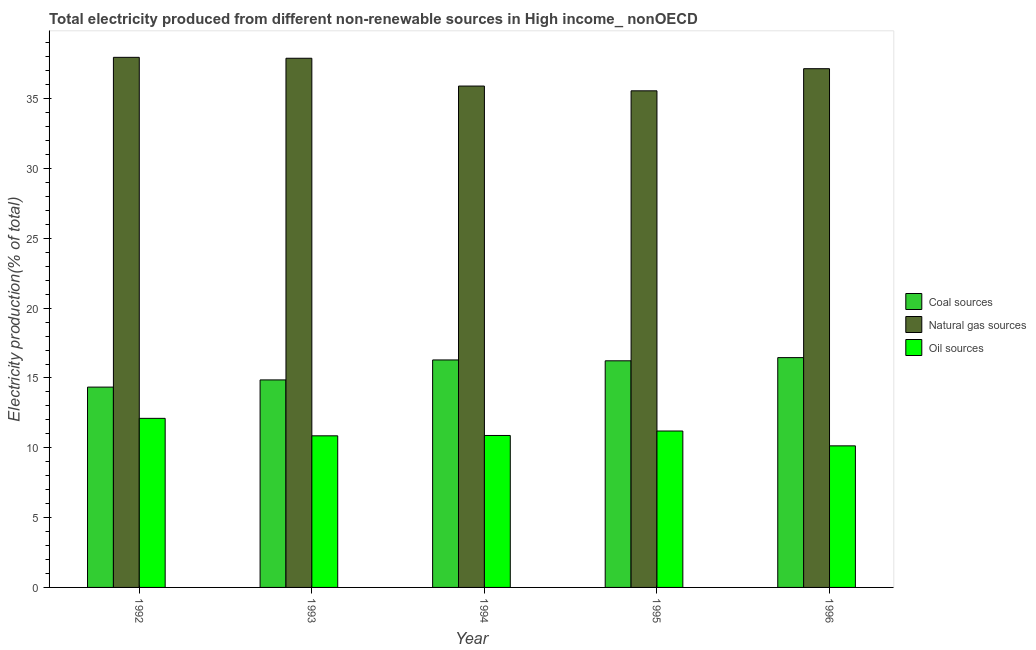How many bars are there on the 4th tick from the left?
Make the answer very short. 3. How many bars are there on the 3rd tick from the right?
Your answer should be compact. 3. What is the label of the 2nd group of bars from the left?
Your answer should be compact. 1993. What is the percentage of electricity produced by natural gas in 1996?
Offer a very short reply. 37.15. Across all years, what is the maximum percentage of electricity produced by oil sources?
Your answer should be very brief. 12.11. Across all years, what is the minimum percentage of electricity produced by coal?
Ensure brevity in your answer.  14.35. What is the total percentage of electricity produced by coal in the graph?
Your answer should be compact. 78.19. What is the difference between the percentage of electricity produced by coal in 1992 and that in 1994?
Provide a short and direct response. -1.95. What is the difference between the percentage of electricity produced by natural gas in 1993 and the percentage of electricity produced by coal in 1992?
Your response must be concise. -0.07. What is the average percentage of electricity produced by natural gas per year?
Your response must be concise. 36.9. In how many years, is the percentage of electricity produced by coal greater than 16 %?
Ensure brevity in your answer.  3. What is the ratio of the percentage of electricity produced by coal in 1993 to that in 1996?
Offer a terse response. 0.9. Is the difference between the percentage of electricity produced by oil sources in 1995 and 1996 greater than the difference between the percentage of electricity produced by natural gas in 1995 and 1996?
Keep it short and to the point. No. What is the difference between the highest and the second highest percentage of electricity produced by coal?
Offer a very short reply. 0.17. What is the difference between the highest and the lowest percentage of electricity produced by natural gas?
Offer a very short reply. 2.4. What does the 1st bar from the left in 1995 represents?
Keep it short and to the point. Coal sources. What does the 3rd bar from the right in 1992 represents?
Offer a terse response. Coal sources. Is it the case that in every year, the sum of the percentage of electricity produced by coal and percentage of electricity produced by natural gas is greater than the percentage of electricity produced by oil sources?
Your response must be concise. Yes. How many years are there in the graph?
Ensure brevity in your answer.  5. What is the difference between two consecutive major ticks on the Y-axis?
Keep it short and to the point. 5. Does the graph contain grids?
Offer a terse response. No. Where does the legend appear in the graph?
Offer a very short reply. Center right. How many legend labels are there?
Your answer should be compact. 3. What is the title of the graph?
Ensure brevity in your answer.  Total electricity produced from different non-renewable sources in High income_ nonOECD. What is the label or title of the X-axis?
Ensure brevity in your answer.  Year. What is the label or title of the Y-axis?
Your response must be concise. Electricity production(% of total). What is the Electricity production(% of total) of Coal sources in 1992?
Give a very brief answer. 14.35. What is the Electricity production(% of total) in Natural gas sources in 1992?
Make the answer very short. 37.97. What is the Electricity production(% of total) in Oil sources in 1992?
Your answer should be compact. 12.11. What is the Electricity production(% of total) in Coal sources in 1993?
Keep it short and to the point. 14.86. What is the Electricity production(% of total) in Natural gas sources in 1993?
Offer a terse response. 37.9. What is the Electricity production(% of total) in Oil sources in 1993?
Provide a short and direct response. 10.86. What is the Electricity production(% of total) in Coal sources in 1994?
Offer a terse response. 16.29. What is the Electricity production(% of total) of Natural gas sources in 1994?
Provide a succinct answer. 35.91. What is the Electricity production(% of total) in Oil sources in 1994?
Provide a succinct answer. 10.88. What is the Electricity production(% of total) in Coal sources in 1995?
Your answer should be very brief. 16.23. What is the Electricity production(% of total) of Natural gas sources in 1995?
Your response must be concise. 35.57. What is the Electricity production(% of total) in Oil sources in 1995?
Give a very brief answer. 11.2. What is the Electricity production(% of total) in Coal sources in 1996?
Provide a short and direct response. 16.46. What is the Electricity production(% of total) in Natural gas sources in 1996?
Give a very brief answer. 37.15. What is the Electricity production(% of total) in Oil sources in 1996?
Provide a short and direct response. 10.14. Across all years, what is the maximum Electricity production(% of total) in Coal sources?
Ensure brevity in your answer.  16.46. Across all years, what is the maximum Electricity production(% of total) in Natural gas sources?
Your answer should be compact. 37.97. Across all years, what is the maximum Electricity production(% of total) in Oil sources?
Offer a very short reply. 12.11. Across all years, what is the minimum Electricity production(% of total) of Coal sources?
Offer a very short reply. 14.35. Across all years, what is the minimum Electricity production(% of total) of Natural gas sources?
Offer a terse response. 35.57. Across all years, what is the minimum Electricity production(% of total) in Oil sources?
Provide a succinct answer. 10.14. What is the total Electricity production(% of total) of Coal sources in the graph?
Ensure brevity in your answer.  78.19. What is the total Electricity production(% of total) of Natural gas sources in the graph?
Your answer should be compact. 184.5. What is the total Electricity production(% of total) of Oil sources in the graph?
Keep it short and to the point. 55.19. What is the difference between the Electricity production(% of total) in Coal sources in 1992 and that in 1993?
Provide a short and direct response. -0.52. What is the difference between the Electricity production(% of total) in Natural gas sources in 1992 and that in 1993?
Ensure brevity in your answer.  0.07. What is the difference between the Electricity production(% of total) of Oil sources in 1992 and that in 1993?
Your response must be concise. 1.25. What is the difference between the Electricity production(% of total) in Coal sources in 1992 and that in 1994?
Offer a very short reply. -1.95. What is the difference between the Electricity production(% of total) in Natural gas sources in 1992 and that in 1994?
Ensure brevity in your answer.  2.06. What is the difference between the Electricity production(% of total) of Oil sources in 1992 and that in 1994?
Give a very brief answer. 1.23. What is the difference between the Electricity production(% of total) in Coal sources in 1992 and that in 1995?
Keep it short and to the point. -1.88. What is the difference between the Electricity production(% of total) in Natural gas sources in 1992 and that in 1995?
Provide a short and direct response. 2.4. What is the difference between the Electricity production(% of total) in Oil sources in 1992 and that in 1995?
Ensure brevity in your answer.  0.91. What is the difference between the Electricity production(% of total) of Coal sources in 1992 and that in 1996?
Ensure brevity in your answer.  -2.11. What is the difference between the Electricity production(% of total) of Natural gas sources in 1992 and that in 1996?
Your response must be concise. 0.81. What is the difference between the Electricity production(% of total) in Oil sources in 1992 and that in 1996?
Your answer should be very brief. 1.97. What is the difference between the Electricity production(% of total) of Coal sources in 1993 and that in 1994?
Provide a succinct answer. -1.43. What is the difference between the Electricity production(% of total) in Natural gas sources in 1993 and that in 1994?
Provide a succinct answer. 1.99. What is the difference between the Electricity production(% of total) in Oil sources in 1993 and that in 1994?
Provide a short and direct response. -0.02. What is the difference between the Electricity production(% of total) of Coal sources in 1993 and that in 1995?
Your response must be concise. -1.37. What is the difference between the Electricity production(% of total) in Natural gas sources in 1993 and that in 1995?
Your answer should be compact. 2.33. What is the difference between the Electricity production(% of total) of Oil sources in 1993 and that in 1995?
Offer a very short reply. -0.34. What is the difference between the Electricity production(% of total) of Coal sources in 1993 and that in 1996?
Your response must be concise. -1.6. What is the difference between the Electricity production(% of total) in Natural gas sources in 1993 and that in 1996?
Your answer should be compact. 0.75. What is the difference between the Electricity production(% of total) in Oil sources in 1993 and that in 1996?
Provide a succinct answer. 0.72. What is the difference between the Electricity production(% of total) in Coal sources in 1994 and that in 1995?
Your answer should be compact. 0.06. What is the difference between the Electricity production(% of total) in Natural gas sources in 1994 and that in 1995?
Keep it short and to the point. 0.34. What is the difference between the Electricity production(% of total) of Oil sources in 1994 and that in 1995?
Your response must be concise. -0.32. What is the difference between the Electricity production(% of total) of Coal sources in 1994 and that in 1996?
Provide a succinct answer. -0.17. What is the difference between the Electricity production(% of total) of Natural gas sources in 1994 and that in 1996?
Your response must be concise. -1.24. What is the difference between the Electricity production(% of total) of Oil sources in 1994 and that in 1996?
Your answer should be compact. 0.74. What is the difference between the Electricity production(% of total) of Coal sources in 1995 and that in 1996?
Your answer should be compact. -0.23. What is the difference between the Electricity production(% of total) of Natural gas sources in 1995 and that in 1996?
Make the answer very short. -1.58. What is the difference between the Electricity production(% of total) of Oil sources in 1995 and that in 1996?
Offer a terse response. 1.06. What is the difference between the Electricity production(% of total) in Coal sources in 1992 and the Electricity production(% of total) in Natural gas sources in 1993?
Offer a terse response. -23.55. What is the difference between the Electricity production(% of total) of Coal sources in 1992 and the Electricity production(% of total) of Oil sources in 1993?
Ensure brevity in your answer.  3.49. What is the difference between the Electricity production(% of total) of Natural gas sources in 1992 and the Electricity production(% of total) of Oil sources in 1993?
Offer a terse response. 27.11. What is the difference between the Electricity production(% of total) in Coal sources in 1992 and the Electricity production(% of total) in Natural gas sources in 1994?
Your response must be concise. -21.56. What is the difference between the Electricity production(% of total) in Coal sources in 1992 and the Electricity production(% of total) in Oil sources in 1994?
Keep it short and to the point. 3.46. What is the difference between the Electricity production(% of total) of Natural gas sources in 1992 and the Electricity production(% of total) of Oil sources in 1994?
Provide a short and direct response. 27.08. What is the difference between the Electricity production(% of total) of Coal sources in 1992 and the Electricity production(% of total) of Natural gas sources in 1995?
Your answer should be compact. -21.22. What is the difference between the Electricity production(% of total) of Coal sources in 1992 and the Electricity production(% of total) of Oil sources in 1995?
Provide a succinct answer. 3.14. What is the difference between the Electricity production(% of total) in Natural gas sources in 1992 and the Electricity production(% of total) in Oil sources in 1995?
Offer a terse response. 26.76. What is the difference between the Electricity production(% of total) of Coal sources in 1992 and the Electricity production(% of total) of Natural gas sources in 1996?
Offer a terse response. -22.81. What is the difference between the Electricity production(% of total) in Coal sources in 1992 and the Electricity production(% of total) in Oil sources in 1996?
Your answer should be compact. 4.21. What is the difference between the Electricity production(% of total) in Natural gas sources in 1992 and the Electricity production(% of total) in Oil sources in 1996?
Give a very brief answer. 27.83. What is the difference between the Electricity production(% of total) of Coal sources in 1993 and the Electricity production(% of total) of Natural gas sources in 1994?
Your response must be concise. -21.05. What is the difference between the Electricity production(% of total) in Coal sources in 1993 and the Electricity production(% of total) in Oil sources in 1994?
Provide a succinct answer. 3.98. What is the difference between the Electricity production(% of total) in Natural gas sources in 1993 and the Electricity production(% of total) in Oil sources in 1994?
Give a very brief answer. 27.02. What is the difference between the Electricity production(% of total) of Coal sources in 1993 and the Electricity production(% of total) of Natural gas sources in 1995?
Ensure brevity in your answer.  -20.71. What is the difference between the Electricity production(% of total) in Coal sources in 1993 and the Electricity production(% of total) in Oil sources in 1995?
Offer a terse response. 3.66. What is the difference between the Electricity production(% of total) in Natural gas sources in 1993 and the Electricity production(% of total) in Oil sources in 1995?
Offer a terse response. 26.7. What is the difference between the Electricity production(% of total) of Coal sources in 1993 and the Electricity production(% of total) of Natural gas sources in 1996?
Provide a succinct answer. -22.29. What is the difference between the Electricity production(% of total) of Coal sources in 1993 and the Electricity production(% of total) of Oil sources in 1996?
Give a very brief answer. 4.72. What is the difference between the Electricity production(% of total) of Natural gas sources in 1993 and the Electricity production(% of total) of Oil sources in 1996?
Give a very brief answer. 27.76. What is the difference between the Electricity production(% of total) in Coal sources in 1994 and the Electricity production(% of total) in Natural gas sources in 1995?
Keep it short and to the point. -19.28. What is the difference between the Electricity production(% of total) in Coal sources in 1994 and the Electricity production(% of total) in Oil sources in 1995?
Make the answer very short. 5.09. What is the difference between the Electricity production(% of total) of Natural gas sources in 1994 and the Electricity production(% of total) of Oil sources in 1995?
Provide a short and direct response. 24.71. What is the difference between the Electricity production(% of total) in Coal sources in 1994 and the Electricity production(% of total) in Natural gas sources in 1996?
Keep it short and to the point. -20.86. What is the difference between the Electricity production(% of total) of Coal sources in 1994 and the Electricity production(% of total) of Oil sources in 1996?
Give a very brief answer. 6.15. What is the difference between the Electricity production(% of total) of Natural gas sources in 1994 and the Electricity production(% of total) of Oil sources in 1996?
Provide a short and direct response. 25.77. What is the difference between the Electricity production(% of total) in Coal sources in 1995 and the Electricity production(% of total) in Natural gas sources in 1996?
Provide a short and direct response. -20.92. What is the difference between the Electricity production(% of total) in Coal sources in 1995 and the Electricity production(% of total) in Oil sources in 1996?
Your answer should be compact. 6.09. What is the difference between the Electricity production(% of total) in Natural gas sources in 1995 and the Electricity production(% of total) in Oil sources in 1996?
Your answer should be very brief. 25.43. What is the average Electricity production(% of total) in Coal sources per year?
Your answer should be very brief. 15.64. What is the average Electricity production(% of total) of Natural gas sources per year?
Your response must be concise. 36.9. What is the average Electricity production(% of total) in Oil sources per year?
Your answer should be very brief. 11.04. In the year 1992, what is the difference between the Electricity production(% of total) of Coal sources and Electricity production(% of total) of Natural gas sources?
Offer a very short reply. -23.62. In the year 1992, what is the difference between the Electricity production(% of total) in Coal sources and Electricity production(% of total) in Oil sources?
Provide a succinct answer. 2.24. In the year 1992, what is the difference between the Electricity production(% of total) of Natural gas sources and Electricity production(% of total) of Oil sources?
Your answer should be very brief. 25.86. In the year 1993, what is the difference between the Electricity production(% of total) of Coal sources and Electricity production(% of total) of Natural gas sources?
Provide a succinct answer. -23.04. In the year 1993, what is the difference between the Electricity production(% of total) in Coal sources and Electricity production(% of total) in Oil sources?
Your answer should be compact. 4. In the year 1993, what is the difference between the Electricity production(% of total) of Natural gas sources and Electricity production(% of total) of Oil sources?
Ensure brevity in your answer.  27.04. In the year 1994, what is the difference between the Electricity production(% of total) of Coal sources and Electricity production(% of total) of Natural gas sources?
Your answer should be compact. -19.62. In the year 1994, what is the difference between the Electricity production(% of total) in Coal sources and Electricity production(% of total) in Oil sources?
Keep it short and to the point. 5.41. In the year 1994, what is the difference between the Electricity production(% of total) in Natural gas sources and Electricity production(% of total) in Oil sources?
Your response must be concise. 25.03. In the year 1995, what is the difference between the Electricity production(% of total) of Coal sources and Electricity production(% of total) of Natural gas sources?
Offer a terse response. -19.34. In the year 1995, what is the difference between the Electricity production(% of total) of Coal sources and Electricity production(% of total) of Oil sources?
Make the answer very short. 5.03. In the year 1995, what is the difference between the Electricity production(% of total) of Natural gas sources and Electricity production(% of total) of Oil sources?
Your response must be concise. 24.37. In the year 1996, what is the difference between the Electricity production(% of total) of Coal sources and Electricity production(% of total) of Natural gas sources?
Offer a very short reply. -20.69. In the year 1996, what is the difference between the Electricity production(% of total) in Coal sources and Electricity production(% of total) in Oil sources?
Keep it short and to the point. 6.32. In the year 1996, what is the difference between the Electricity production(% of total) of Natural gas sources and Electricity production(% of total) of Oil sources?
Your answer should be compact. 27.01. What is the ratio of the Electricity production(% of total) of Coal sources in 1992 to that in 1993?
Offer a very short reply. 0.97. What is the ratio of the Electricity production(% of total) in Natural gas sources in 1992 to that in 1993?
Keep it short and to the point. 1. What is the ratio of the Electricity production(% of total) of Oil sources in 1992 to that in 1993?
Offer a very short reply. 1.12. What is the ratio of the Electricity production(% of total) in Coal sources in 1992 to that in 1994?
Provide a short and direct response. 0.88. What is the ratio of the Electricity production(% of total) of Natural gas sources in 1992 to that in 1994?
Keep it short and to the point. 1.06. What is the ratio of the Electricity production(% of total) in Oil sources in 1992 to that in 1994?
Ensure brevity in your answer.  1.11. What is the ratio of the Electricity production(% of total) of Coal sources in 1992 to that in 1995?
Make the answer very short. 0.88. What is the ratio of the Electricity production(% of total) in Natural gas sources in 1992 to that in 1995?
Provide a succinct answer. 1.07. What is the ratio of the Electricity production(% of total) in Oil sources in 1992 to that in 1995?
Provide a succinct answer. 1.08. What is the ratio of the Electricity production(% of total) in Coal sources in 1992 to that in 1996?
Your answer should be very brief. 0.87. What is the ratio of the Electricity production(% of total) of Natural gas sources in 1992 to that in 1996?
Offer a very short reply. 1.02. What is the ratio of the Electricity production(% of total) in Oil sources in 1992 to that in 1996?
Provide a succinct answer. 1.19. What is the ratio of the Electricity production(% of total) of Coal sources in 1993 to that in 1994?
Ensure brevity in your answer.  0.91. What is the ratio of the Electricity production(% of total) in Natural gas sources in 1993 to that in 1994?
Your answer should be compact. 1.06. What is the ratio of the Electricity production(% of total) in Coal sources in 1993 to that in 1995?
Give a very brief answer. 0.92. What is the ratio of the Electricity production(% of total) in Natural gas sources in 1993 to that in 1995?
Offer a very short reply. 1.07. What is the ratio of the Electricity production(% of total) of Oil sources in 1993 to that in 1995?
Your response must be concise. 0.97. What is the ratio of the Electricity production(% of total) of Coal sources in 1993 to that in 1996?
Keep it short and to the point. 0.9. What is the ratio of the Electricity production(% of total) in Natural gas sources in 1993 to that in 1996?
Provide a short and direct response. 1.02. What is the ratio of the Electricity production(% of total) in Oil sources in 1993 to that in 1996?
Make the answer very short. 1.07. What is the ratio of the Electricity production(% of total) of Natural gas sources in 1994 to that in 1995?
Keep it short and to the point. 1.01. What is the ratio of the Electricity production(% of total) in Oil sources in 1994 to that in 1995?
Keep it short and to the point. 0.97. What is the ratio of the Electricity production(% of total) in Coal sources in 1994 to that in 1996?
Make the answer very short. 0.99. What is the ratio of the Electricity production(% of total) of Natural gas sources in 1994 to that in 1996?
Provide a short and direct response. 0.97. What is the ratio of the Electricity production(% of total) of Oil sources in 1994 to that in 1996?
Your answer should be compact. 1.07. What is the ratio of the Electricity production(% of total) in Coal sources in 1995 to that in 1996?
Give a very brief answer. 0.99. What is the ratio of the Electricity production(% of total) in Natural gas sources in 1995 to that in 1996?
Your response must be concise. 0.96. What is the ratio of the Electricity production(% of total) of Oil sources in 1995 to that in 1996?
Your answer should be compact. 1.1. What is the difference between the highest and the second highest Electricity production(% of total) in Coal sources?
Your answer should be compact. 0.17. What is the difference between the highest and the second highest Electricity production(% of total) of Natural gas sources?
Your answer should be very brief. 0.07. What is the difference between the highest and the second highest Electricity production(% of total) in Oil sources?
Ensure brevity in your answer.  0.91. What is the difference between the highest and the lowest Electricity production(% of total) of Coal sources?
Keep it short and to the point. 2.11. What is the difference between the highest and the lowest Electricity production(% of total) in Natural gas sources?
Make the answer very short. 2.4. What is the difference between the highest and the lowest Electricity production(% of total) of Oil sources?
Keep it short and to the point. 1.97. 